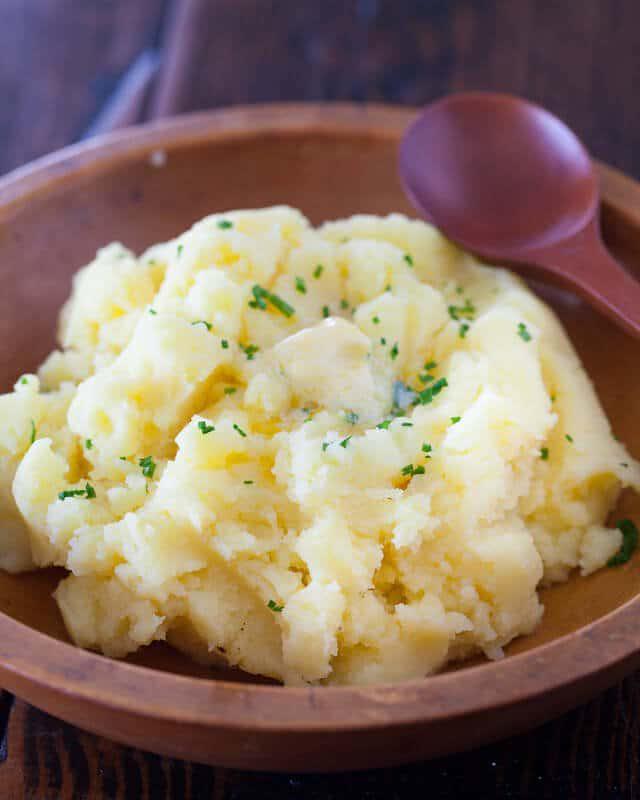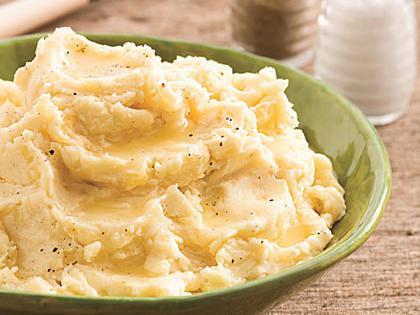The first image is the image on the left, the second image is the image on the right. For the images shown, is this caption "The left and right image contains the same number of bowls of mash potatoes with at least one wooden bowl." true? Answer yes or no. Yes. The first image is the image on the left, the second image is the image on the right. Examine the images to the left and right. Is the description "A spoon is near a round brown bowl of garnished mashed potatoes in the left image." accurate? Answer yes or no. Yes. 